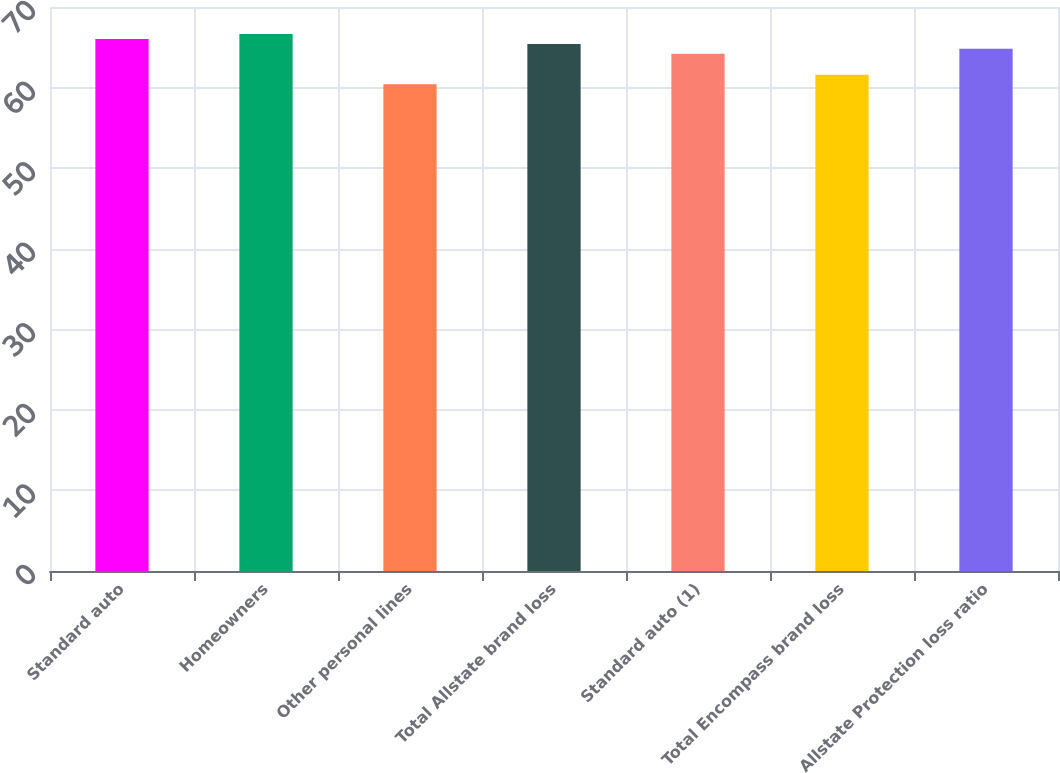<chart> <loc_0><loc_0><loc_500><loc_500><bar_chart><fcel>Standard auto<fcel>Homeowners<fcel>Other personal lines<fcel>Total Allstate brand loss<fcel>Standard auto (1)<fcel>Total Encompass brand loss<fcel>Allstate Protection loss ratio<nl><fcel>66.03<fcel>66.64<fcel>60.4<fcel>65.42<fcel>64.2<fcel>61.6<fcel>64.81<nl></chart> 